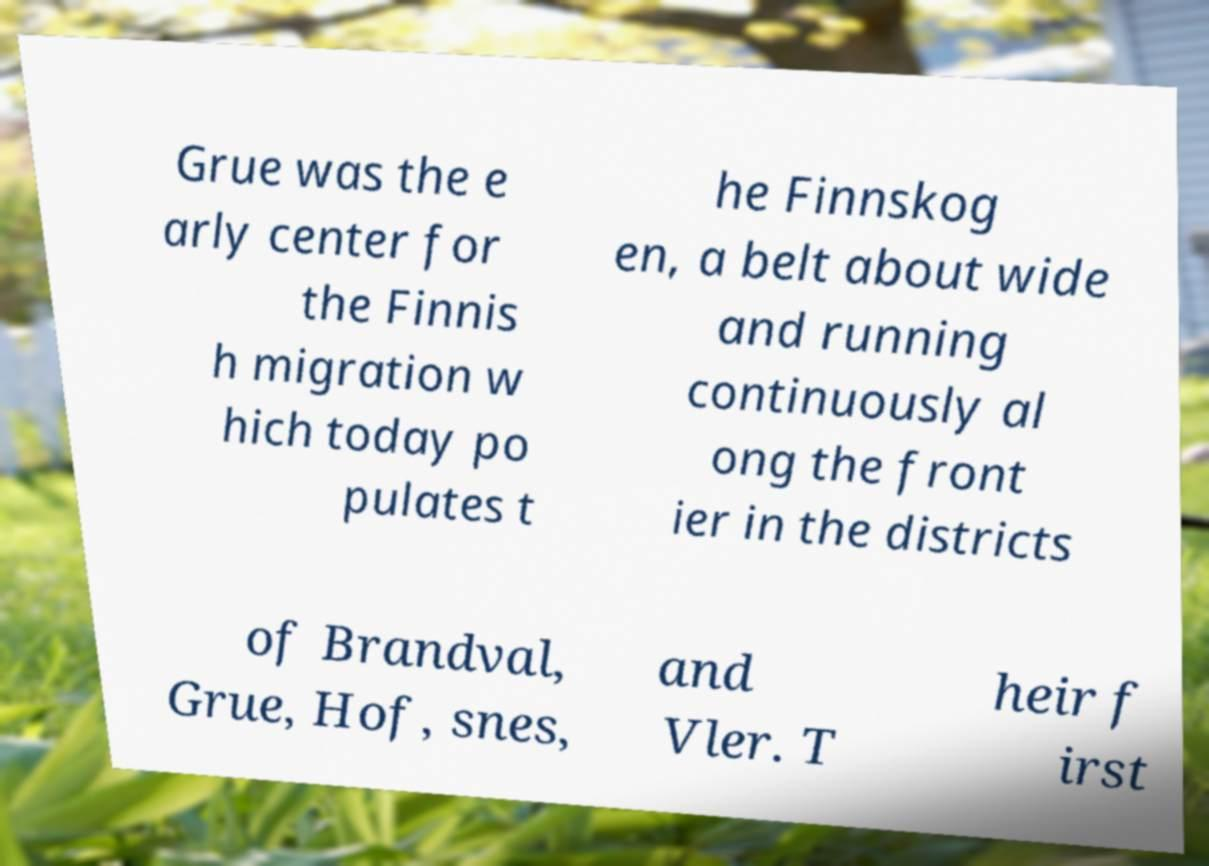I need the written content from this picture converted into text. Can you do that? Grue was the e arly center for the Finnis h migration w hich today po pulates t he Finnskog en, a belt about wide and running continuously al ong the front ier in the districts of Brandval, Grue, Hof, snes, and Vler. T heir f irst 